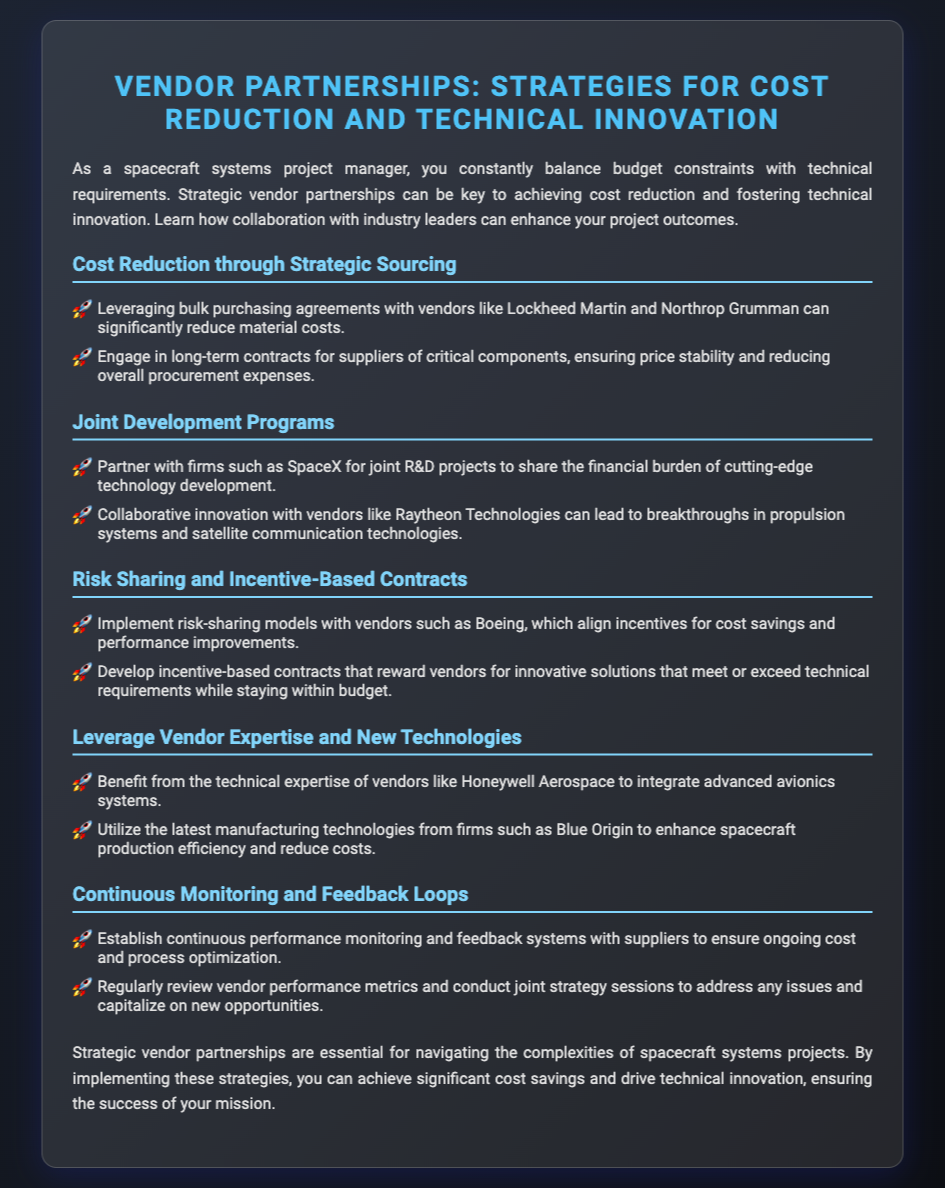what is the main focus of the flyer? The main focus is on strategies for cost reduction and technical innovation through vendor partnerships.
Answer: strategies for cost reduction and technical innovation which company is mentioned for joint R&D projects? SpaceX is specifically referenced as a potential partner for joint R&D projects.
Answer: SpaceX what type of contracts are suggested to align incentives with vendors? Incentive-based contracts are advised to align vendors' incentives for cost savings and performance improvements.
Answer: incentive-based contracts who is mentioned as a vendor for advanced avionics systems? Honeywell Aerospace is noted for their technical expertise in advanced avionics systems.
Answer: Honeywell Aerospace what should be established with suppliers for ongoing optimization? Continuous performance monitoring and feedback systems should be established with suppliers.
Answer: continuous performance monitoring and feedback systems which vendor is recommended for collaborative innovation in propulsion systems? Raytheon Technologies is suggested for collaborative innovation in propulsion systems.
Answer: Raytheon Technologies how can companies achieve price stability in procurement? Engaging in long-term contracts with suppliers of critical components can ensure price stability.
Answer: long-term contracts what is one benefit of leveraging manufacturing technologies? Utilizing the latest manufacturing technologies can enhance spacecraft production efficiency.
Answer: enhance spacecraft production efficiency what is essential for navigating spacecraft systems project complexities? Strategic vendor partnerships are essential for navigating these complexities.
Answer: strategic vendor partnerships 